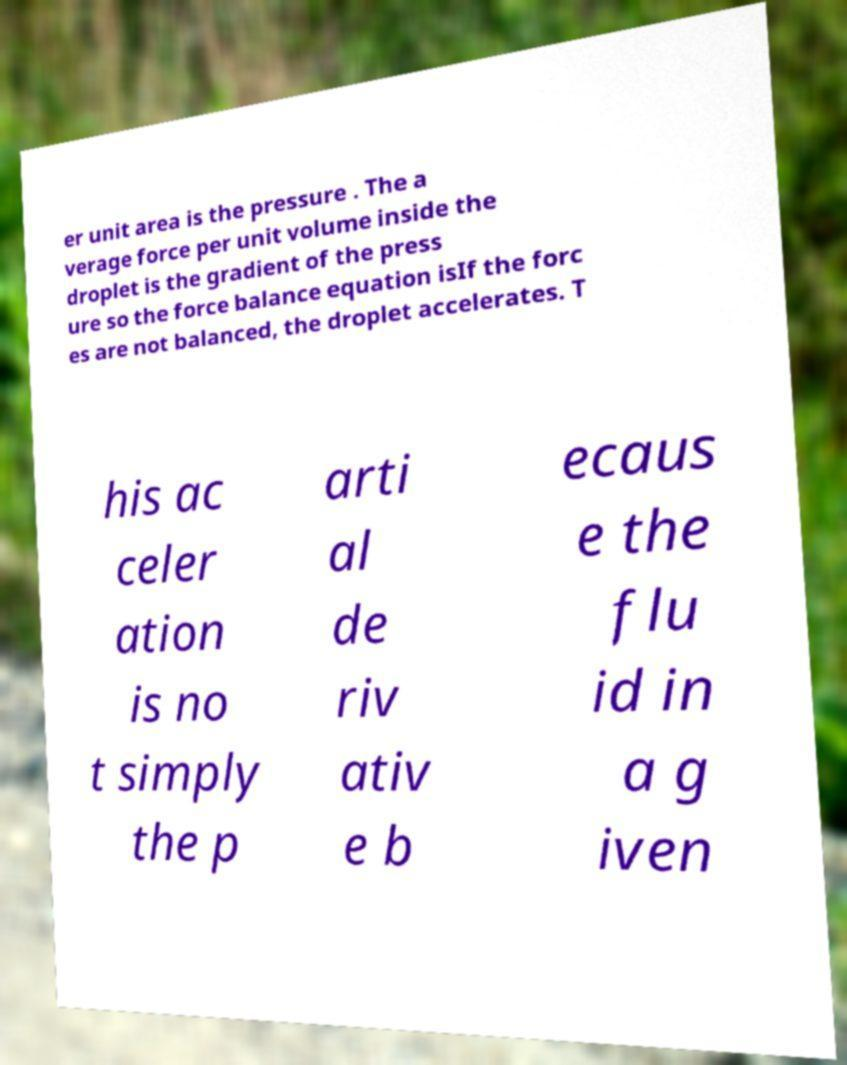Please identify and transcribe the text found in this image. er unit area is the pressure . The a verage force per unit volume inside the droplet is the gradient of the press ure so the force balance equation isIf the forc es are not balanced, the droplet accelerates. T his ac celer ation is no t simply the p arti al de riv ativ e b ecaus e the flu id in a g iven 